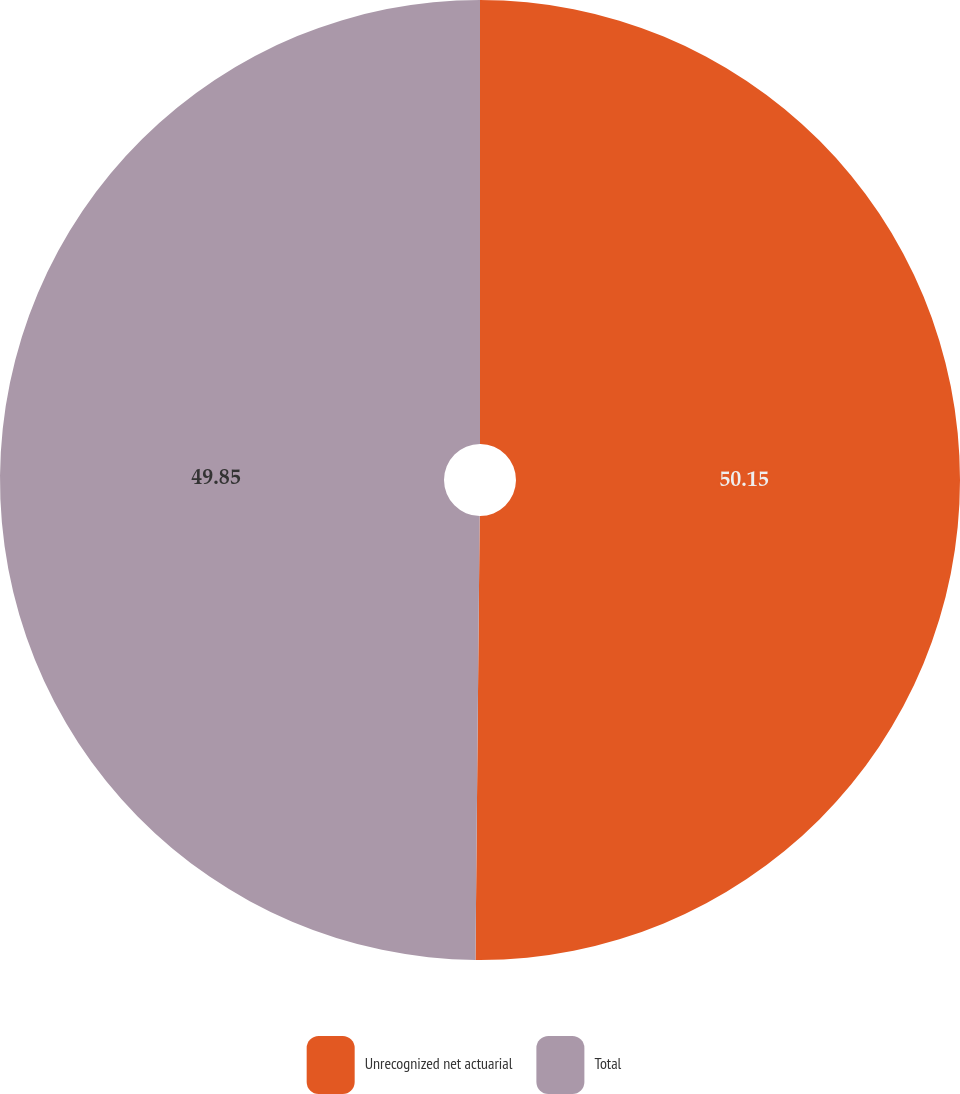<chart> <loc_0><loc_0><loc_500><loc_500><pie_chart><fcel>Unrecognized net actuarial<fcel>Total<nl><fcel>50.15%<fcel>49.85%<nl></chart> 